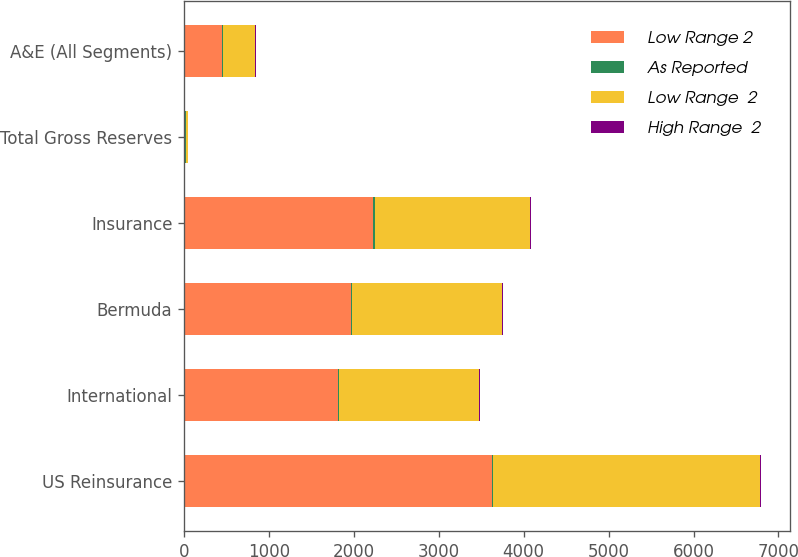Convert chart to OTSL. <chart><loc_0><loc_0><loc_500><loc_500><stacked_bar_chart><ecel><fcel>US Reinsurance<fcel>International<fcel>Bermuda<fcel>Insurance<fcel>Total Gross Reserves<fcel>A&E (All Segments)<nl><fcel>Low Range 2<fcel>3621.2<fcel>1816.8<fcel>1962<fcel>2226.2<fcel>15.8<fcel>442.9<nl><fcel>As Reported<fcel>13<fcel>9.3<fcel>9.9<fcel>17.9<fcel>9.2<fcel>13.7<nl><fcel>Low Range  2<fcel>3151.8<fcel>1647.1<fcel>1768.7<fcel>1827.8<fcel>15.8<fcel>382.2<nl><fcel>High Range  2<fcel>13<fcel>9.3<fcel>9.9<fcel>17.9<fcel>9.2<fcel>13.7<nl></chart> 